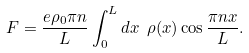Convert formula to latex. <formula><loc_0><loc_0><loc_500><loc_500>F = \frac { e \rho _ { 0 } \pi n } { L } \int _ { 0 } ^ { L } d x \ \rho ( x ) \cos \frac { \pi n x } { L } .</formula> 